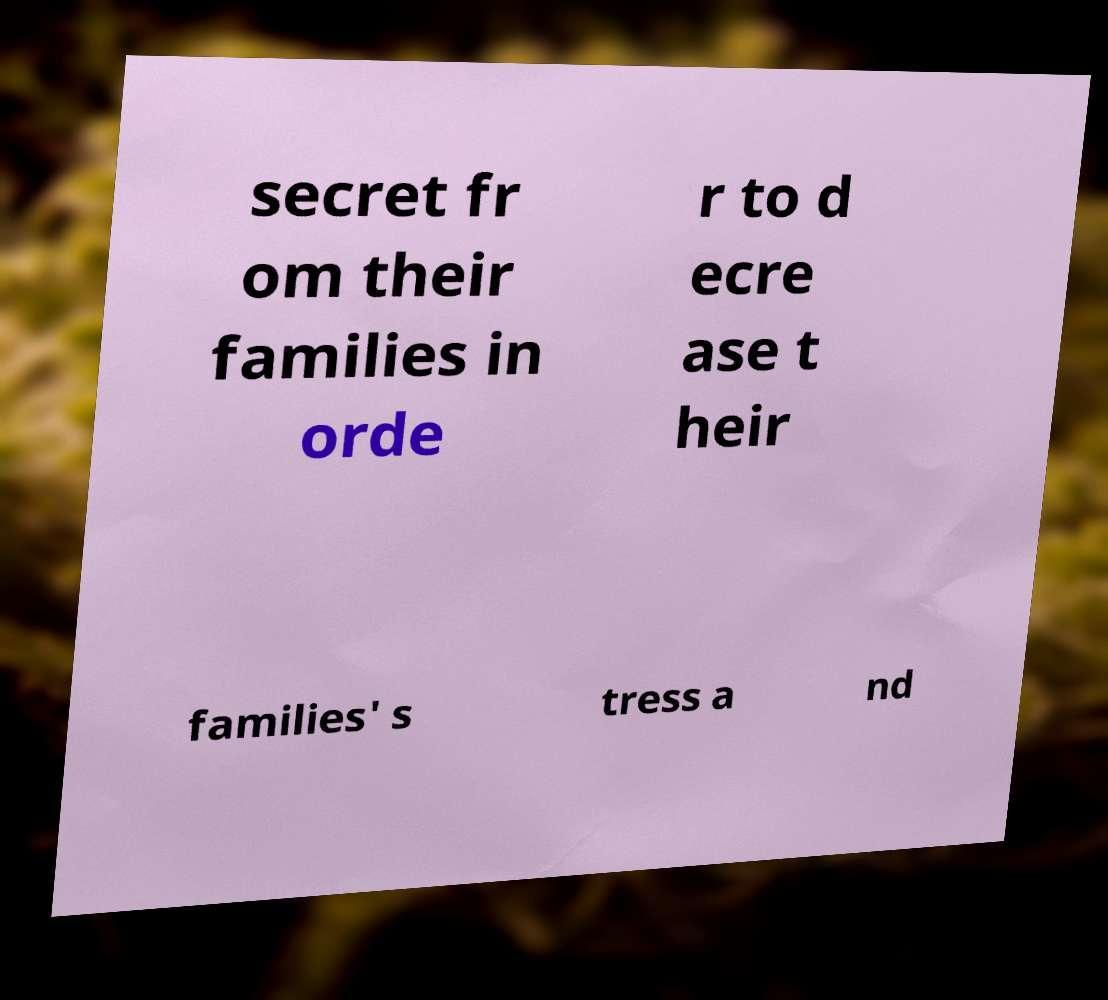Can you accurately transcribe the text from the provided image for me? secret fr om their families in orde r to d ecre ase t heir families' s tress a nd 